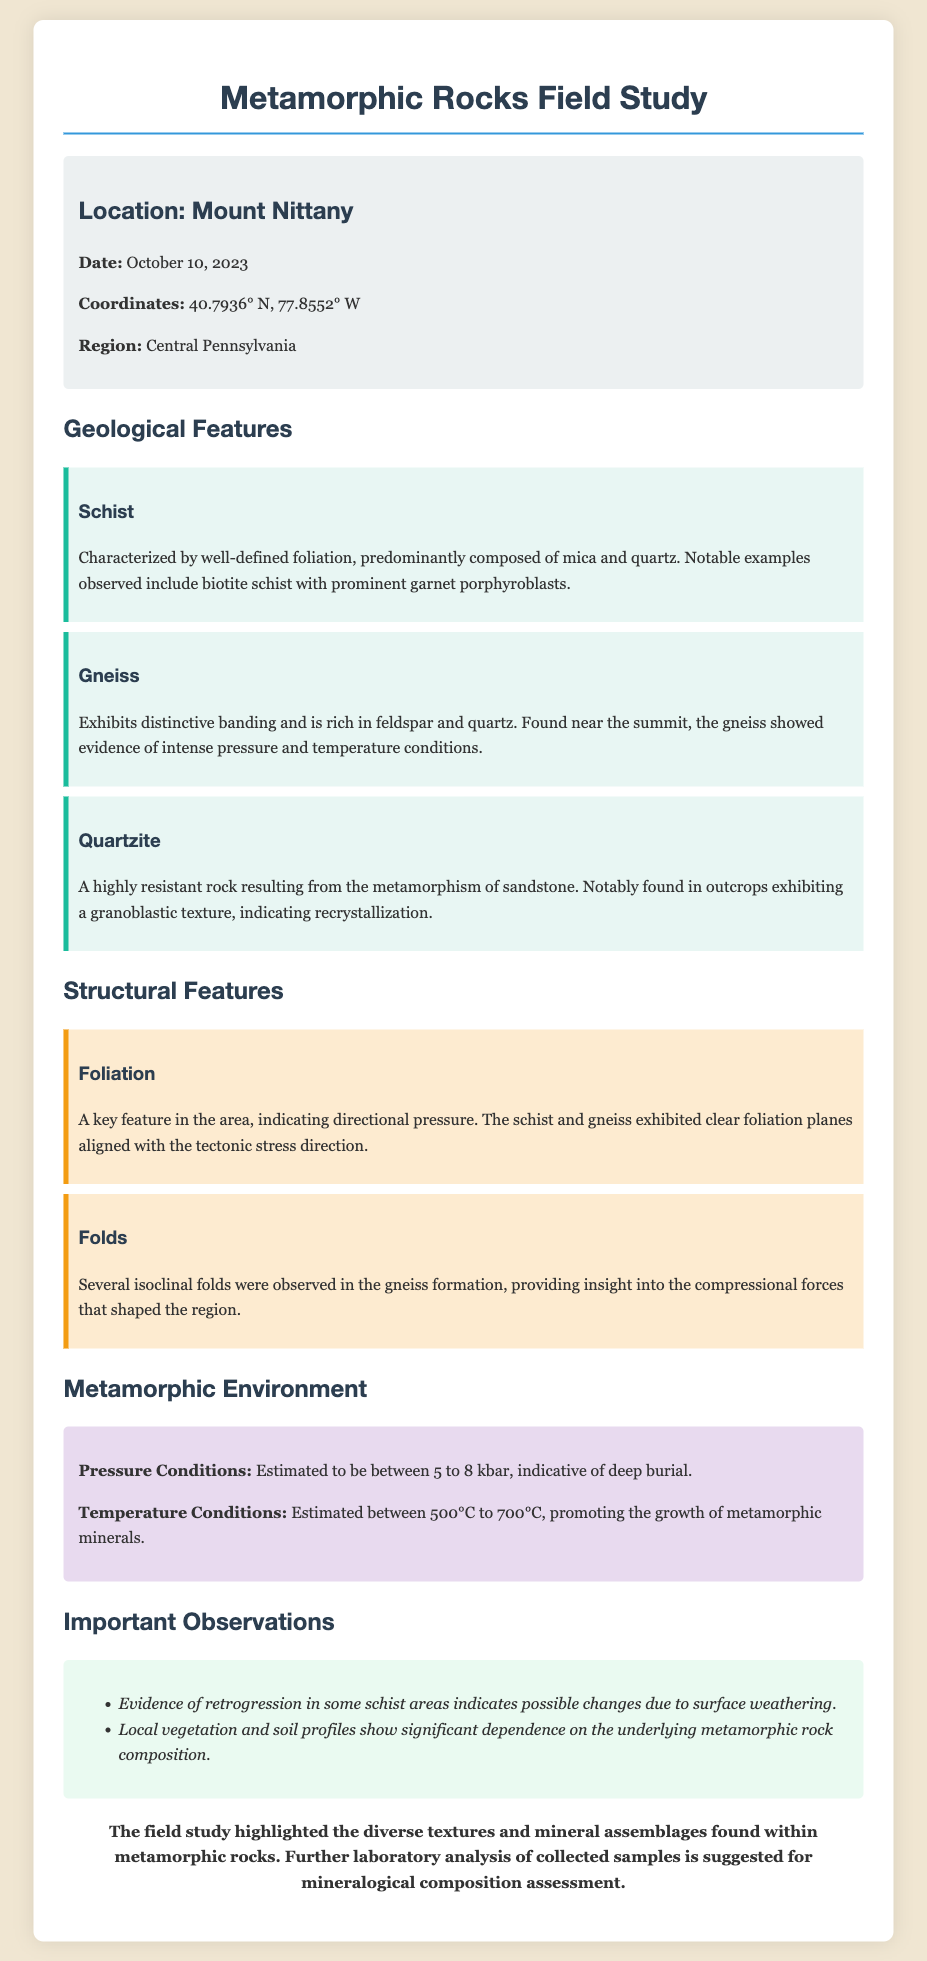What is the location of the field study? The location of the field study is specified in the document as Mount Nittany.
Answer: Mount Nittany What type of rock exhibits well-defined foliation? The document mentions schist as characterized by well-defined foliation.
Answer: Schist What is the estimated pressure condition mentioned? The document states the estimated pressure conditions to be between 5 to 8 kbar.
Answer: 5 to 8 kbar What type of folds were observed in the gneiss formation? The document describes the observation of several isoclinal folds in the gneiss formation.
Answer: Isoclinal What mineral showed retrogression in some schist areas? The presence of retrogression in areas is specifically related to schist in the document.
Answer: Schist Which metamorphic rock is described as resulting from sandstone? The document indicates quartzite as a rock formed from the metamorphism of sandstone.
Answer: Quartzite What were the temperature conditions estimated to be? The temperature conditions are estimated to be between 500°C to 700°C as per the document.
Answer: 500°C to 700°C What geological feature indicates directional pressure? The document identifies foliation as a key feature indicating directional pressure.
Answer: Foliation What is suggested for further study of collected samples? The document recommends further laboratory analysis of collected samples for assessment.
Answer: Laboratory analysis 